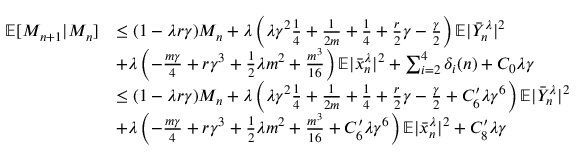<formula> <loc_0><loc_0><loc_500><loc_500>\begin{array} { r l } { \mathbb { E } [ M _ { n + 1 } | M _ { n } ] } & { \leq ( 1 - \lambda r \gamma ) M _ { n } + \lambda \left ( \lambda \gamma ^ { 2 } \frac { 1 } { 4 } + \frac { 1 } { 2 m } + \frac { 1 } { 4 } + \frac { r } { 2 } \gamma - \frac { \gamma } { 2 } \right ) \mathbb { E } | \bar { Y } _ { n } ^ { \lambda } | ^ { 2 } } \\ & { + \lambda \left ( - \frac { m \gamma } { 4 } + r \gamma ^ { 3 } + \frac { 1 } { 2 } \lambda m ^ { 2 } + \frac { m ^ { 3 } } { 1 6 } \right ) \mathbb { E } | \bar { x } _ { n } ^ { \lambda } | ^ { 2 } + \sum _ { i = 2 } ^ { 4 } \delta _ { i } ( n ) + C _ { 0 } \lambda \gamma } \\ & { \leq ( 1 - \lambda r \gamma ) M _ { n } + \lambda \left ( \lambda \gamma ^ { 2 } \frac { 1 } { 4 } + \frac { 1 } { 2 m } + \frac { 1 } { 4 } + \frac { r } { 2 } \gamma - \frac { \gamma } { 2 } + C _ { 6 } ^ { \prime } \lambda \gamma ^ { 6 } \right ) \mathbb { E } | \bar { Y } _ { n } ^ { \lambda } | ^ { 2 } } \\ & { + \lambda \left ( - \frac { m \gamma } { 4 } + r \gamma ^ { 3 } + \frac { 1 } { 2 } \lambda m ^ { 2 } + \frac { m ^ { 3 } } { 1 6 } + C _ { 6 } ^ { \prime } \lambda \gamma ^ { 6 } \right ) \mathbb { E } | \bar { x } _ { n } ^ { \lambda } | ^ { 2 } + C _ { 8 } ^ { \prime } \lambda \gamma } \end{array}</formula> 